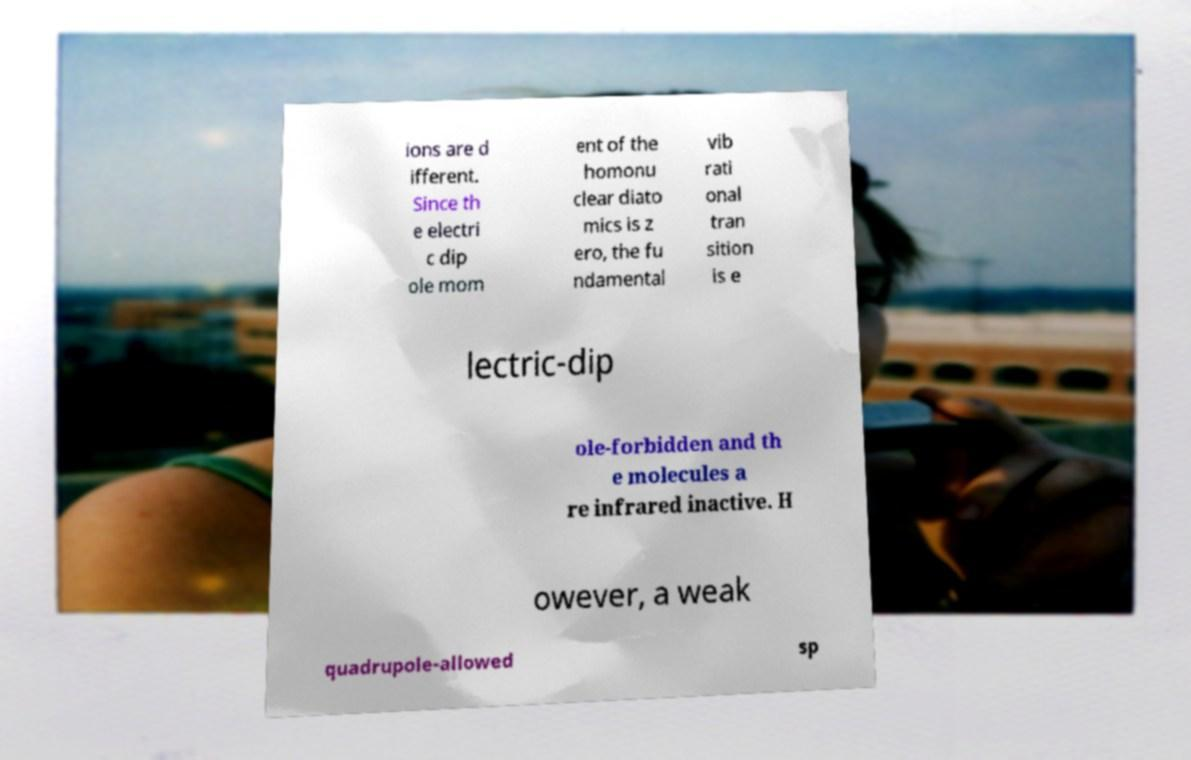Please read and relay the text visible in this image. What does it say? ions are d ifferent. Since th e electri c dip ole mom ent of the homonu clear diato mics is z ero, the fu ndamental vib rati onal tran sition is e lectric-dip ole-forbidden and th e molecules a re infrared inactive. H owever, a weak quadrupole-allowed sp 